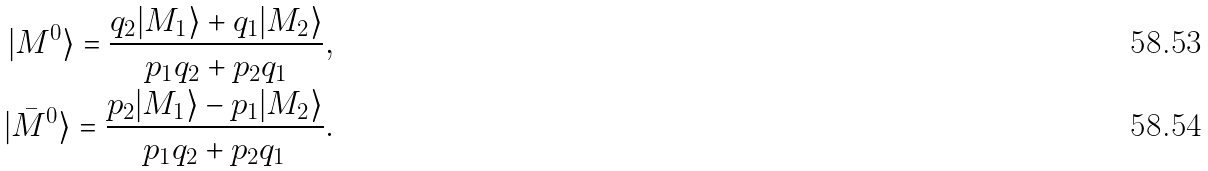<formula> <loc_0><loc_0><loc_500><loc_500>| M ^ { 0 } \rangle = \frac { q _ { 2 } | M _ { 1 } \rangle + q _ { 1 } | M _ { 2 } \rangle } { p _ { 1 } q _ { 2 } + p _ { 2 } q _ { 1 } } , \\ | \bar { M } ^ { 0 } \rangle = \frac { p _ { 2 } | M _ { 1 } \rangle - p _ { 1 } | M _ { 2 } \rangle } { p _ { 1 } q _ { 2 } + p _ { 2 } q _ { 1 } } .</formula> 